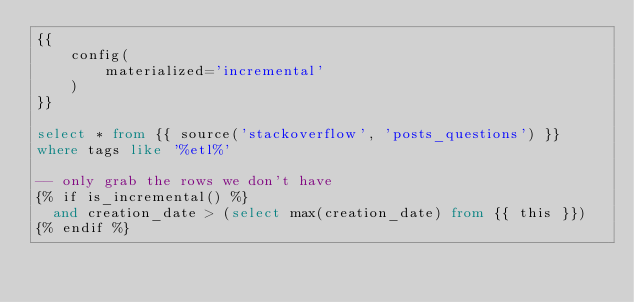<code> <loc_0><loc_0><loc_500><loc_500><_SQL_>{{
    config(
        materialized='incremental'
    )
}}

select * from {{ source('stackoverflow', 'posts_questions') }}
where tags like '%etl%'

-- only grab the rows we don't have
{% if is_incremental() %}
  and creation_date > (select max(creation_date) from {{ this }})
{% endif %}
</code> 